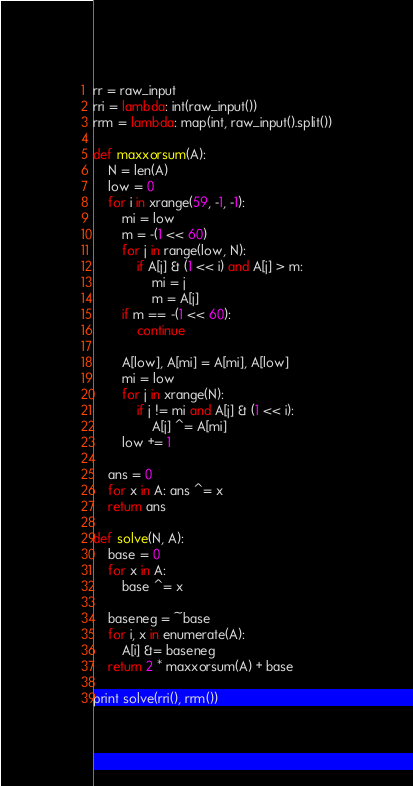Convert code to text. <code><loc_0><loc_0><loc_500><loc_500><_Python_>rr = raw_input
rri = lambda: int(raw_input())
rrm = lambda: map(int, raw_input().split())

def maxxorsum(A):
    N = len(A)
    low = 0
    for i in xrange(59, -1, -1):
        mi = low
        m = -(1 << 60)
        for j in range(low, N):
            if A[j] & (1 << i) and A[j] > m:
                mi = j
                m = A[j]
        if m == -(1 << 60):
            continue

        A[low], A[mi] = A[mi], A[low]
        mi = low
        for j in xrange(N):
            if j != mi and A[j] & (1 << i):
                A[j] ^= A[mi]
        low += 1

    ans = 0
    for x in A: ans ^= x
    return ans

def solve(N, A):
    base = 0
    for x in A:
        base ^= x

    baseneg = ~base
    for i, x in enumerate(A):
        A[i] &= baseneg
    return 2 * maxxorsum(A) + base

print solve(rri(), rrm())
</code> 